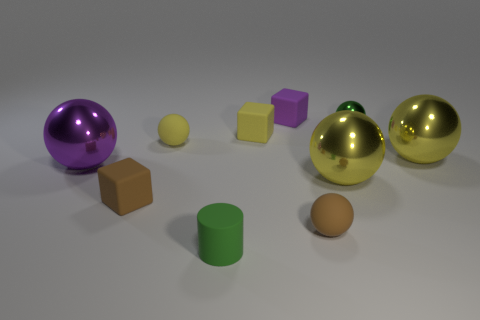What color is the matte ball that is to the left of the tiny purple matte block? The matte ball to the left of the tiny purple matte block is of a radiant yellow color, complementing the purple's cool tone with its warm hue. 